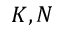Convert formula to latex. <formula><loc_0><loc_0><loc_500><loc_500>K , N</formula> 